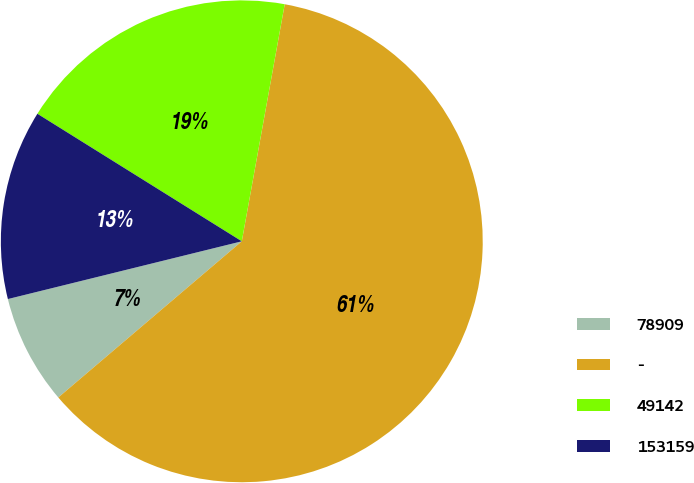<chart> <loc_0><loc_0><loc_500><loc_500><pie_chart><fcel>78909<fcel>-<fcel>49142<fcel>153159<nl><fcel>7.37%<fcel>60.92%<fcel>18.97%<fcel>12.73%<nl></chart> 